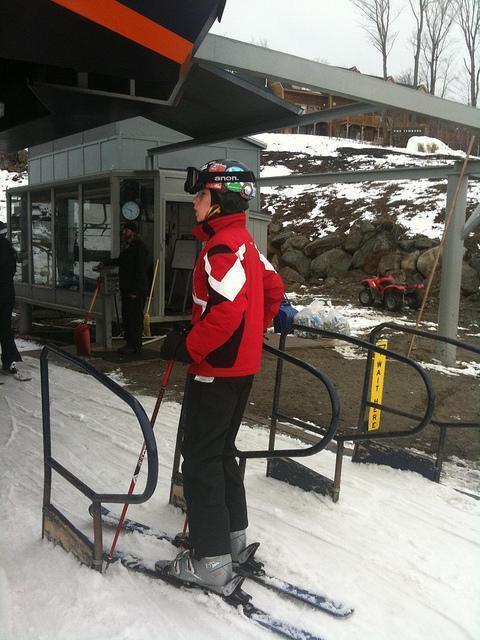What are the bars for?
Pick the correct solution from the four options below to address the question.
Options: Holds poles, holds skis, stand waiting, holds clothing. Stand waiting. What is the person in red most likely awaiting a turn for?
Select the accurate answer and provide explanation: 'Answer: answer
Rationale: rationale.'
Options: Snow blower, snow cat, ski lift, bus. Answer: ski lift.
Rationale: The person in red has on skis and ski/snow suit with glove and ski poles.  the person shown is ready to ski so he is probably waiting for a ride to the top of the ski slopes. 